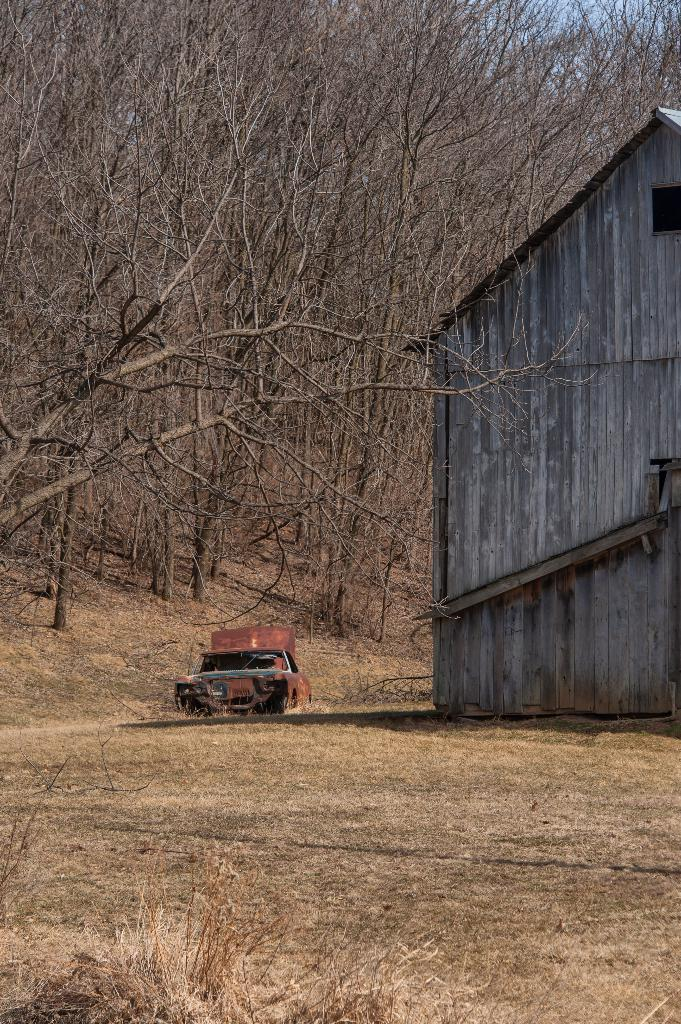What is the main subject of the image? There is a vehicle on the road in the image. What can be seen on the right side of the image? There is a house on the right side of the image. What type of vegetation is on the left side of the image? There are dry trees on the left side of the image. What type of wall can be seen surrounding the town in the image? There is no town or wall present in the image; it only features a vehicle on the road, a house on the right side, and dry trees on the left side. 